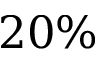<formula> <loc_0><loc_0><loc_500><loc_500>2 0 \%</formula> 